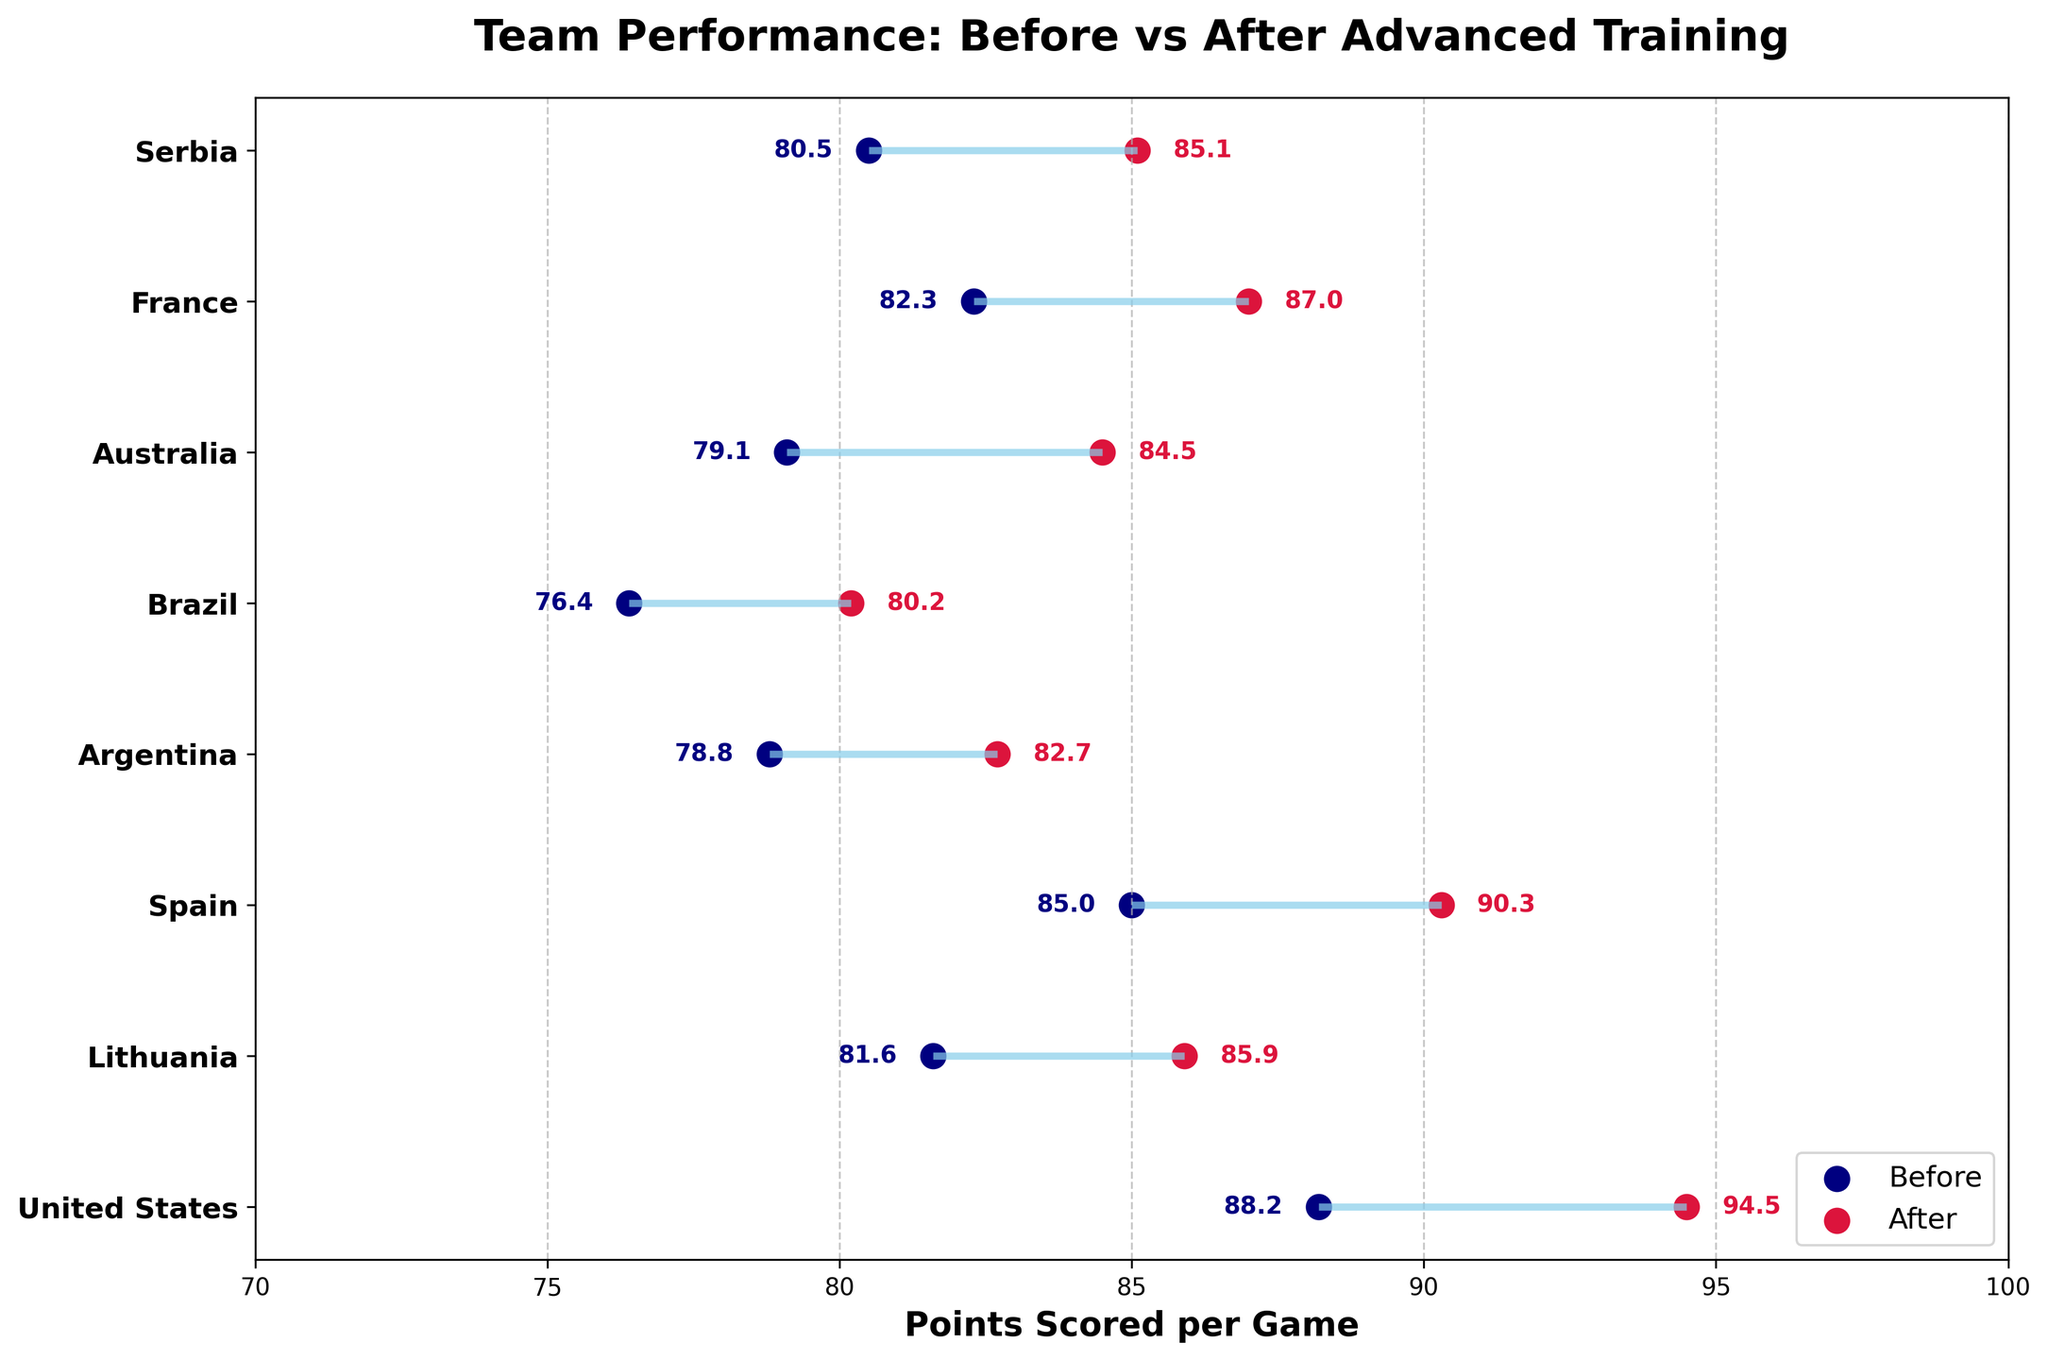What's the title of the figure? The title of a figure is usually displayed at the top and summarizes the main focus of the plot, in this case highlighting the comparison of team performance before and after implementing advanced training techniques.
Answer: Team Performance: Before vs After Advanced Training What does the x-axis represent? The x-axis is labeled 'Points Scored per Game,' indicating it represents the number of points each team scores in a game both before and after implementing advanced training techniques.
Answer: Points Scored per Game How many teams are represented in the figure? By counting the number of different teams listed on the y-axis, we can determine the number of teams represented in the plot.
Answer: 8 Which team had the highest increase in points scored after implementing advanced training techniques? To find this, we need to calculate the difference between the 'Points Scored After' and 'Points Scored Before' for each team. The team with the largest difference has the highest increase. For the United States, it is 94.5 - 88.2 = 6.3, which is the highest.
Answer: United States What is the average points scored before implementing advanced training techniques for all teams? To find the average, sum all the 'Points Scored Before' values and divide by the number of teams: (88.2 + 81.6 + 85.0 + 78.8 + 76.4 + 79.1 + 82.3 + 80.5) / 8 = 82.36.
Answer: 82.36 Which team scored fewer points after implementing advanced training techniques compared to other teams? By comparing the 'Points Scored After' values across all teams, the team with the lowest value is identified. Brazil has the lowest with a score of 80.2 points.
Answer: Brazil For which team is the difference between points scored before and after the smallest? Calculate the differences between the 'Points Scored After' and 'Points Scored Before' for each team, and identify the team with the smallest difference. Lithuania has the smallest improvement: 85.9 - 81.6 = 4.3.
Answer: Lithuania What's the total increase in points scored per game for all teams combined? Sum the differences for all teams: (94.5 - 88.2) + (85.9 - 81.6) + (90.3 - 85.0) + (82.7 - 78.8) + (80.2 - 76.4) + (84.5 - 79.1) + (87.0 - 82.3) + (85.1 - 80.5) = 31.8.
Answer: 31.8 Between which two teams is the difference in points scored before and after the closest? Calculate the differences for each team and then find the smallest absolute difference between any two teams’ improvements. The closest differences are between France and Spain with improvements of 4.7 and 5.3, respectively. Difference:
Answer: France and Spain 